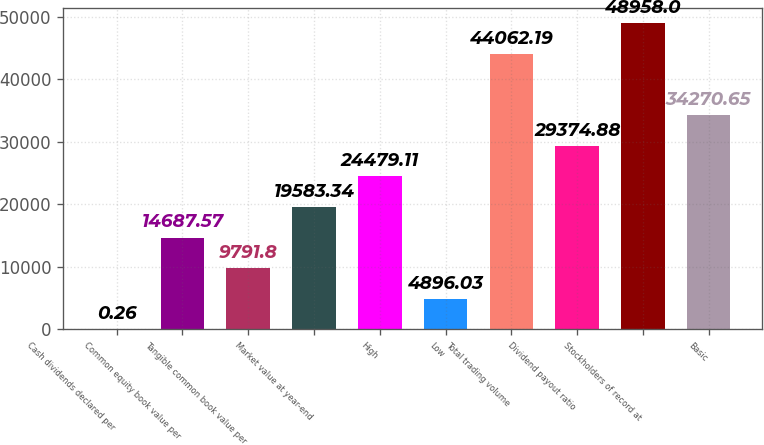Convert chart to OTSL. <chart><loc_0><loc_0><loc_500><loc_500><bar_chart><fcel>Cash dividends declared per<fcel>Common equity book value per<fcel>Tangible common book value per<fcel>Market value at year-end<fcel>High<fcel>Low<fcel>Total trading volume<fcel>Dividend payout ratio<fcel>Stockholders of record at<fcel>Basic<nl><fcel>0.26<fcel>14687.6<fcel>9791.8<fcel>19583.3<fcel>24479.1<fcel>4896.03<fcel>44062.2<fcel>29374.9<fcel>48958<fcel>34270.7<nl></chart> 